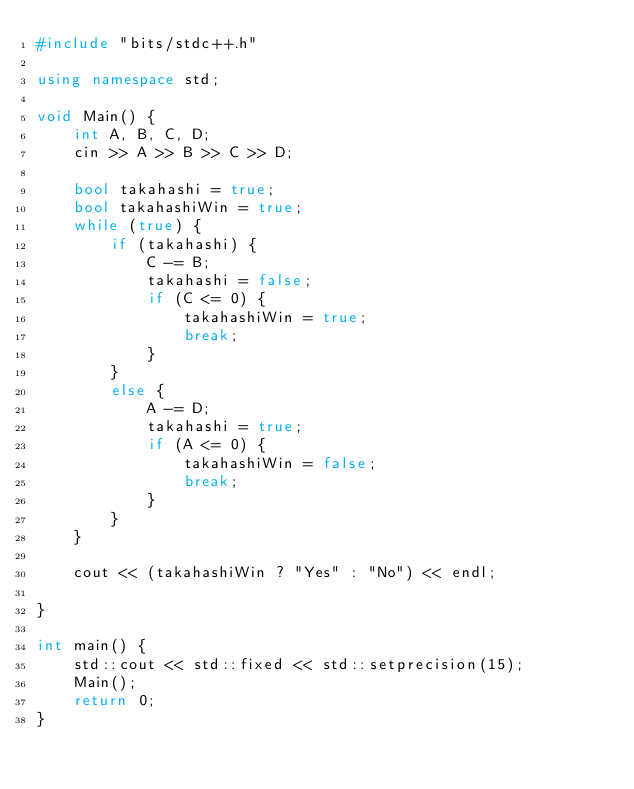<code> <loc_0><loc_0><loc_500><loc_500><_C++_>#include "bits/stdc++.h"

using namespace std;

void Main() {
    int A, B, C, D;
    cin >> A >> B >> C >> D;

    bool takahashi = true;
    bool takahashiWin = true;
    while (true) {
        if (takahashi) {
            C -= B;
            takahashi = false;
            if (C <= 0) {
                takahashiWin = true;
                break;
            }
        }
        else {
            A -= D;
            takahashi = true;
            if (A <= 0) {
                takahashiWin = false;
                break;
            }
        }
    }

    cout << (takahashiWin ? "Yes" : "No") << endl;

}

int main() {
    std::cout << std::fixed << std::setprecision(15);
    Main();
    return 0;
}
</code> 